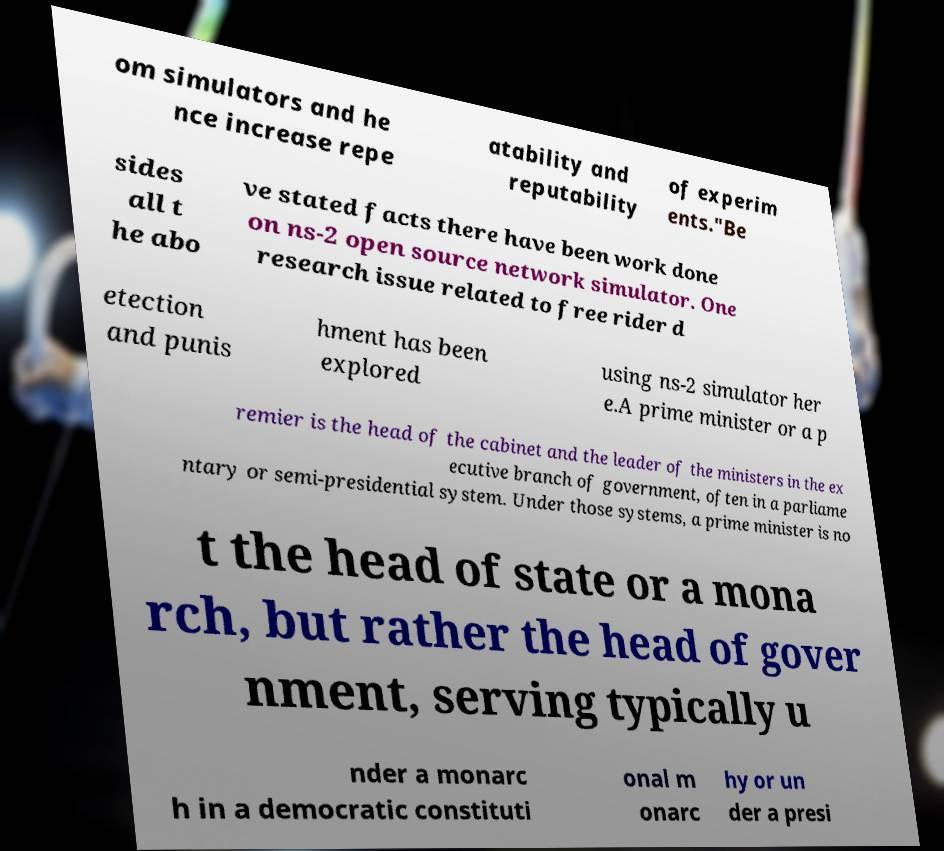Could you assist in decoding the text presented in this image and type it out clearly? om simulators and he nce increase repe atability and reputability of experim ents."Be sides all t he abo ve stated facts there have been work done on ns-2 open source network simulator. One research issue related to free rider d etection and punis hment has been explored using ns-2 simulator her e.A prime minister or a p remier is the head of the cabinet and the leader of the ministers in the ex ecutive branch of government, often in a parliame ntary or semi-presidential system. Under those systems, a prime minister is no t the head of state or a mona rch, but rather the head of gover nment, serving typically u nder a monarc h in a democratic constituti onal m onarc hy or un der a presi 